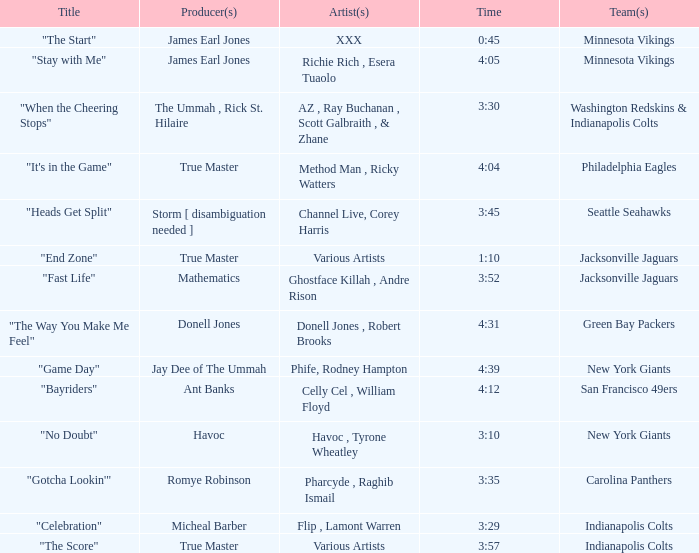How long is the XXX track used by the Minnesota Vikings? 0:45. Would you mind parsing the complete table? {'header': ['Title', 'Producer(s)', 'Artist(s)', 'Time', 'Team(s)'], 'rows': [['"The Start"', 'James Earl Jones', 'XXX', '0:45', 'Minnesota Vikings'], ['"Stay with Me"', 'James Earl Jones', 'Richie Rich , Esera Tuaolo', '4:05', 'Minnesota Vikings'], ['"When the Cheering Stops"', 'The Ummah , Rick St. Hilaire', 'AZ , Ray Buchanan , Scott Galbraith , & Zhane', '3:30', 'Washington Redskins & Indianapolis Colts'], ['"It\'s in the Game"', 'True Master', 'Method Man , Ricky Watters', '4:04', 'Philadelphia Eagles'], ['"Heads Get Split"', 'Storm [ disambiguation needed ]', 'Channel Live, Corey Harris', '3:45', 'Seattle Seahawks'], ['"End Zone"', 'True Master', 'Various Artists', '1:10', 'Jacksonville Jaguars'], ['"Fast Life"', 'Mathematics', 'Ghostface Killah , Andre Rison', '3:52', 'Jacksonville Jaguars'], ['"The Way You Make Me Feel"', 'Donell Jones', 'Donell Jones , Robert Brooks', '4:31', 'Green Bay Packers'], ['"Game Day"', 'Jay Dee of The Ummah', 'Phife, Rodney Hampton', '4:39', 'New York Giants'], ['"Bayriders"', 'Ant Banks', 'Celly Cel , William Floyd', '4:12', 'San Francisco 49ers'], ['"No Doubt"', 'Havoc', 'Havoc , Tyrone Wheatley', '3:10', 'New York Giants'], ['"Gotcha Lookin\'"', 'Romye Robinson', 'Pharcyde , Raghib Ismail', '3:35', 'Carolina Panthers'], ['"Celebration"', 'Micheal Barber', 'Flip , Lamont Warren', '3:29', 'Indianapolis Colts'], ['"The Score"', 'True Master', 'Various Artists', '3:57', 'Indianapolis Colts']]} 